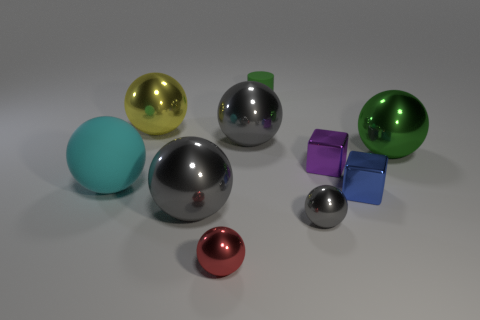Subtract all brown blocks. How many gray spheres are left? 3 Subtract 1 balls. How many balls are left? 6 Subtract all red spheres. How many spheres are left? 6 Subtract all big green balls. How many balls are left? 6 Subtract all purple balls. Subtract all blue cylinders. How many balls are left? 7 Subtract all cylinders. How many objects are left? 9 Add 7 purple metallic things. How many purple metallic things exist? 8 Subtract 0 gray cylinders. How many objects are left? 10 Subtract all cyan things. Subtract all big rubber spheres. How many objects are left? 8 Add 4 cyan objects. How many cyan objects are left? 5 